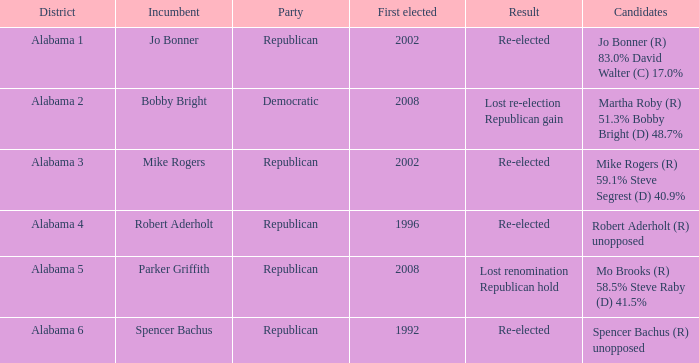Identify the current officeholder for alabama Spencer Bachus. 